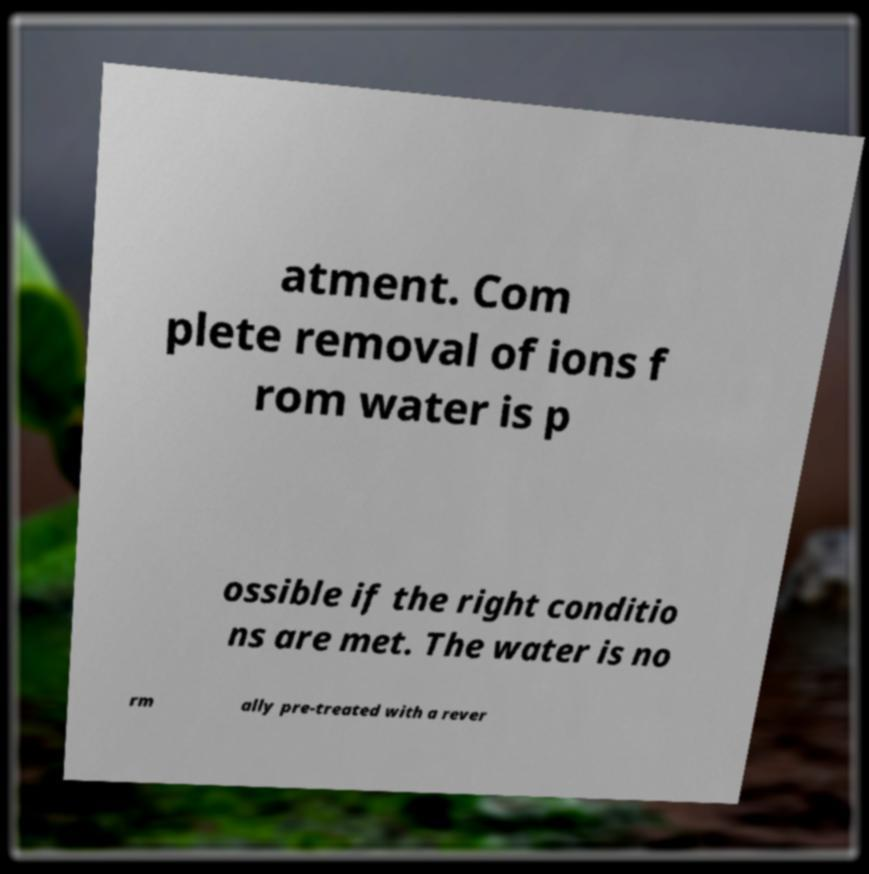Can you read and provide the text displayed in the image?This photo seems to have some interesting text. Can you extract and type it out for me? atment. Com plete removal of ions f rom water is p ossible if the right conditio ns are met. The water is no rm ally pre-treated with a rever 